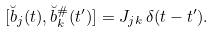Convert formula to latex. <formula><loc_0><loc_0><loc_500><loc_500>[ \breve { b } _ { j } ( t ) , \breve { b } _ { k } ^ { \# } ( t ^ { \prime } ) ] = J _ { j k } \, \delta ( t - t ^ { \prime } ) .</formula> 